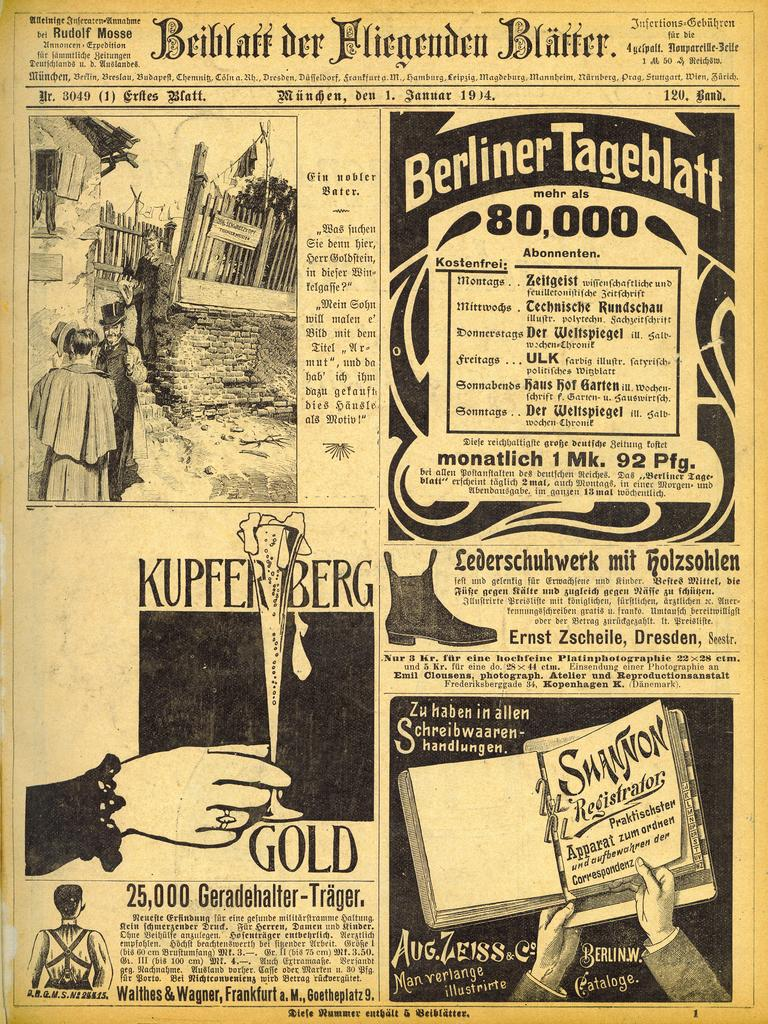What is the main object in the image? There is a poster in the image. What can be seen on the poster? There are people depicted on the poster, and there is text on the poster. What type of smile can be seen on the airplane in the image? There is no airplane present in the image, and therefore no smile to observe. 